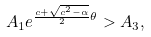Convert formula to latex. <formula><loc_0><loc_0><loc_500><loc_500>A _ { 1 } e ^ { \frac { c + \sqrt { c ^ { 2 } - \alpha } } { 2 } \theta } > A _ { 3 } ,</formula> 